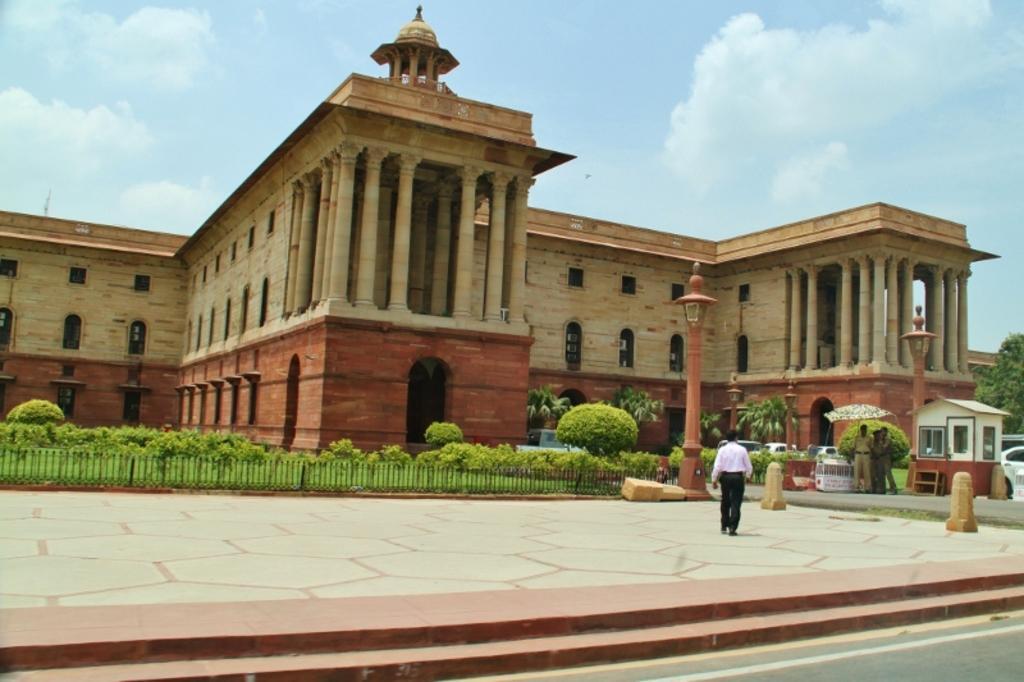Can you describe this image briefly? Here in this picture we can see a monumental building with number of windows present over a place and in the front we can see a person walking on the ground and we can see two persons standing over a place with an umbrella above them and we can also see grass, plants and trees present on the ground and we can see clouds in the sky. 